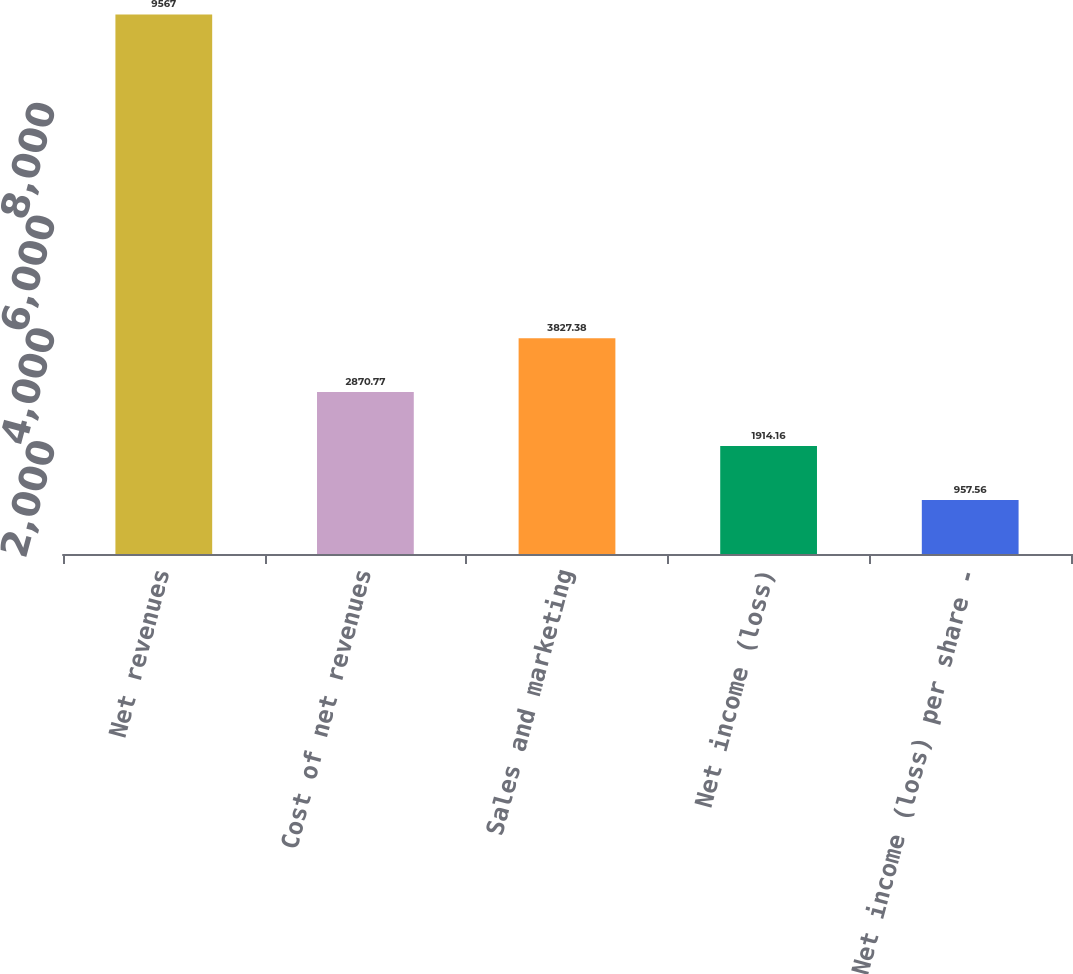Convert chart. <chart><loc_0><loc_0><loc_500><loc_500><bar_chart><fcel>Net revenues<fcel>Cost of net revenues<fcel>Sales and marketing<fcel>Net income (loss)<fcel>Net income (loss) per share -<nl><fcel>9567<fcel>2870.77<fcel>3827.38<fcel>1914.16<fcel>957.56<nl></chart> 